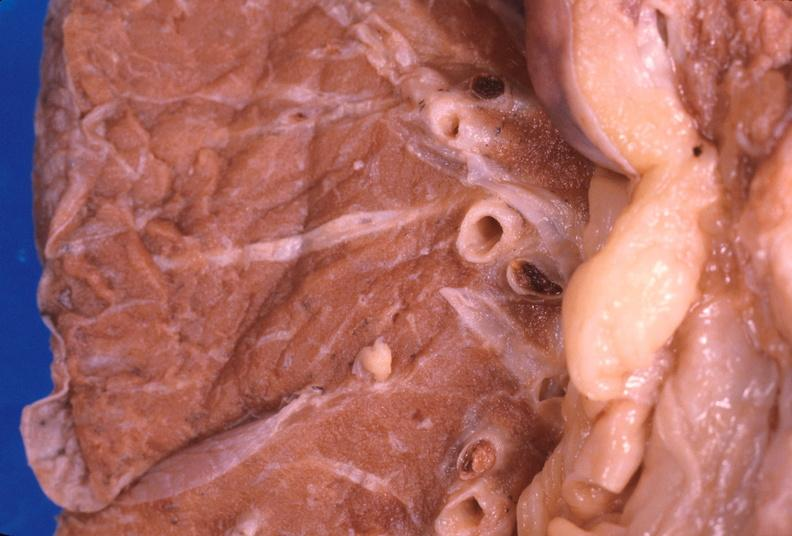does this image show thromboembolus from leg veins in pulmonary artery?
Answer the question using a single word or phrase. Yes 